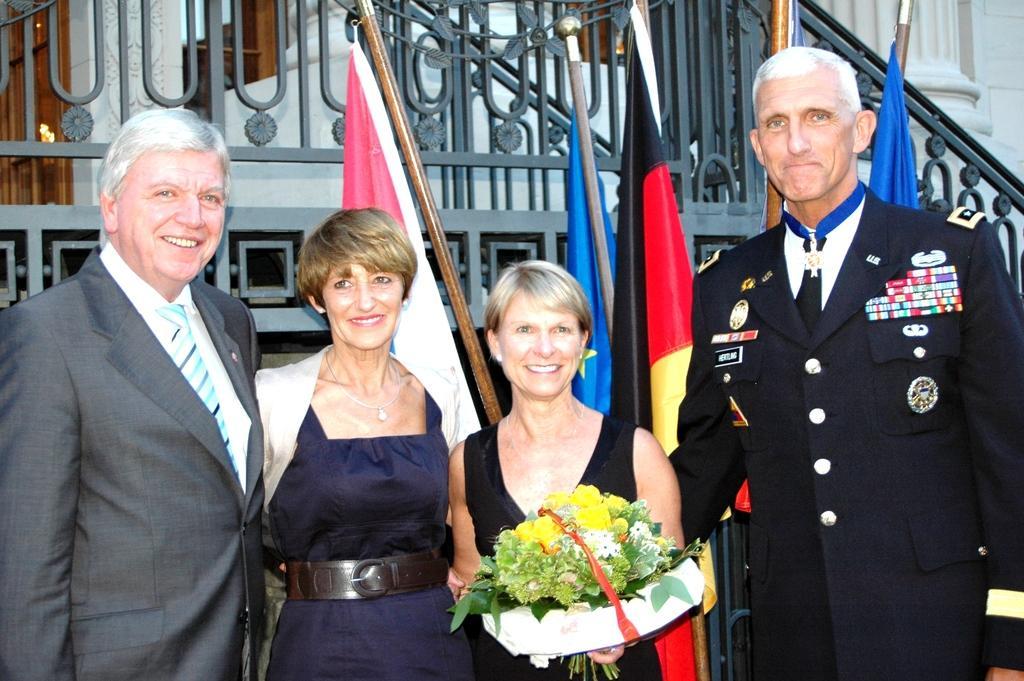Please provide a concise description of this image. In this image we can see people standing. There is a lady holding a bouquet. In the background of the image there are flags, metal railing, wall, pillar. 